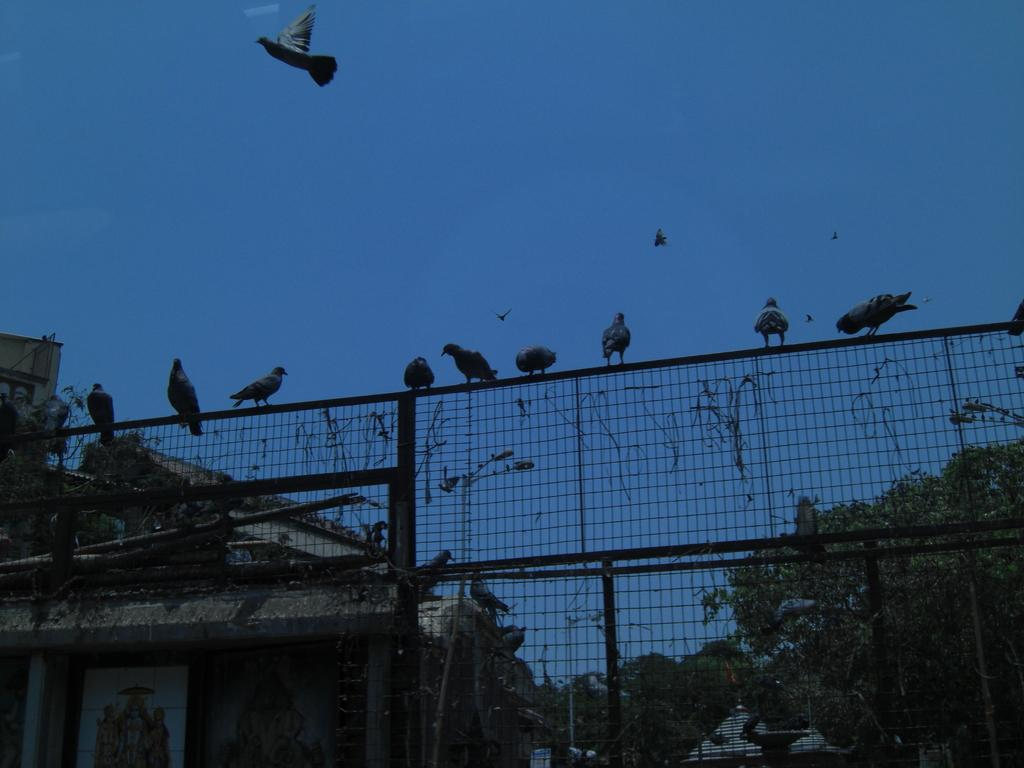What animals can be seen in the foreground of the image? There are birds on the net fencing in the foreground of the image. What type of structures are visible in the background of the image? There are houses in the background of the image. What type of vegetation can be seen in the background of the image? There are trees in the background of the image. What is visible in the sky in the background of the image? The sky is visible in the background of the image. Can you tell me how many grapes are hanging from the trees in the image? There are no grapes visible in the image; only trees are present. What type of kite is being flown by the birds in the image? There are no kites present in the image; only birds on net fencing are visible. 